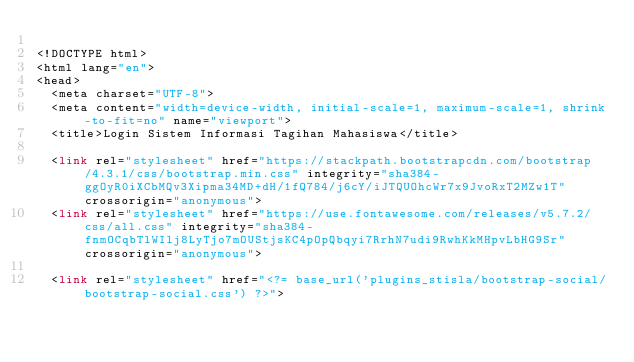Convert code to text. <code><loc_0><loc_0><loc_500><loc_500><_PHP_>
<!DOCTYPE html>
<html lang="en">
<head>
  <meta charset="UTF-8">
  <meta content="width=device-width, initial-scale=1, maximum-scale=1, shrink-to-fit=no" name="viewport">
  <title>Login Sistem Informasi Tagihan Mahasiswa</title>

  <link rel="stylesheet" href="https://stackpath.bootstrapcdn.com/bootstrap/4.3.1/css/bootstrap.min.css" integrity="sha384-ggOyR0iXCbMQv3Xipma34MD+dH/1fQ784/j6cY/iJTQUOhcWr7x9JvoRxT2MZw1T" crossorigin="anonymous">
  <link rel="stylesheet" href="https://use.fontawesome.com/releases/v5.7.2/css/all.css" integrity="sha384-fnmOCqbTlWIlj8LyTjo7mOUStjsKC4pOpQbqyi7RrhN7udi9RwhKkMHpvLbHG9Sr" crossorigin="anonymous">

  <link rel="stylesheet" href="<?= base_url('plugins_stisla/bootstrap-social/bootstrap-social.css') ?>"></code> 